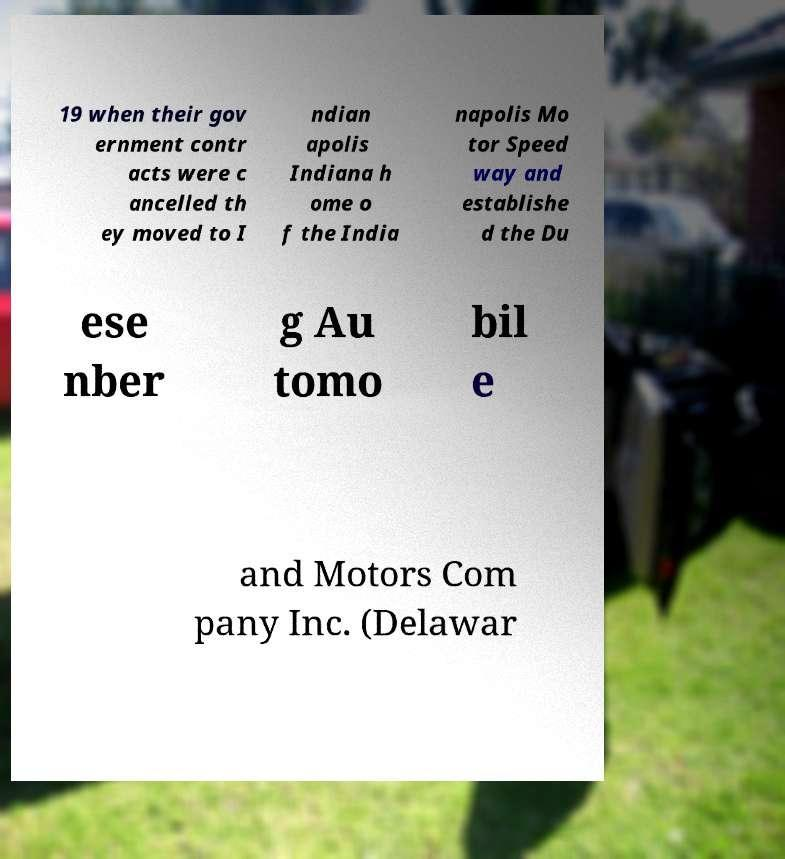I need the written content from this picture converted into text. Can you do that? 19 when their gov ernment contr acts were c ancelled th ey moved to I ndian apolis Indiana h ome o f the India napolis Mo tor Speed way and establishe d the Du ese nber g Au tomo bil e and Motors Com pany Inc. (Delawar 